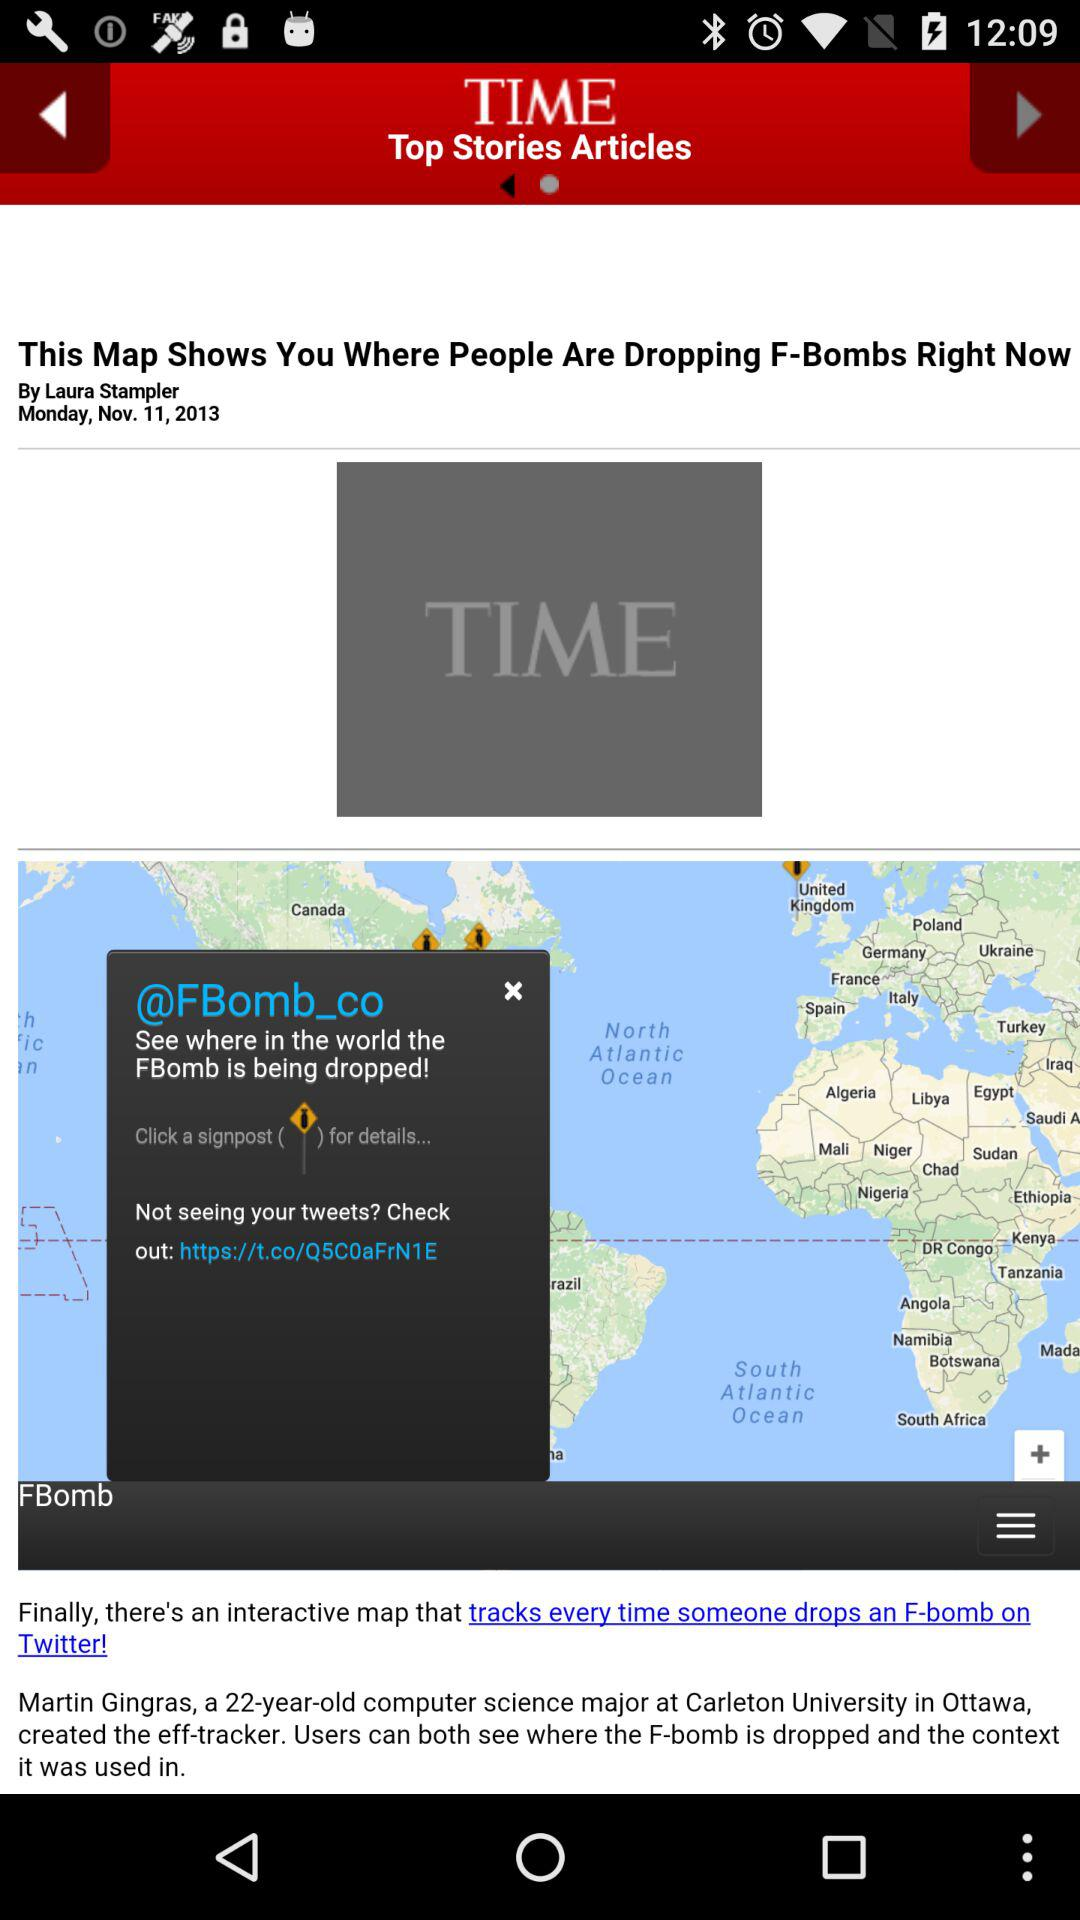Who is the author of this article? The author of this article is Laura Stampler. 